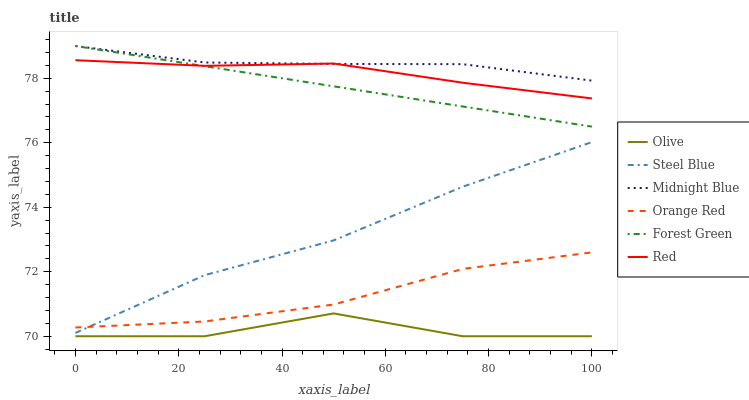Does Olive have the minimum area under the curve?
Answer yes or no. Yes. Does Midnight Blue have the maximum area under the curve?
Answer yes or no. Yes. Does Steel Blue have the minimum area under the curve?
Answer yes or no. No. Does Steel Blue have the maximum area under the curve?
Answer yes or no. No. Is Forest Green the smoothest?
Answer yes or no. Yes. Is Olive the roughest?
Answer yes or no. Yes. Is Steel Blue the smoothest?
Answer yes or no. No. Is Steel Blue the roughest?
Answer yes or no. No. Does Olive have the lowest value?
Answer yes or no. Yes. Does Steel Blue have the lowest value?
Answer yes or no. No. Does Forest Green have the highest value?
Answer yes or no. Yes. Does Steel Blue have the highest value?
Answer yes or no. No. Is Olive less than Forest Green?
Answer yes or no. Yes. Is Orange Red greater than Olive?
Answer yes or no. Yes. Does Orange Red intersect Steel Blue?
Answer yes or no. Yes. Is Orange Red less than Steel Blue?
Answer yes or no. No. Is Orange Red greater than Steel Blue?
Answer yes or no. No. Does Olive intersect Forest Green?
Answer yes or no. No. 